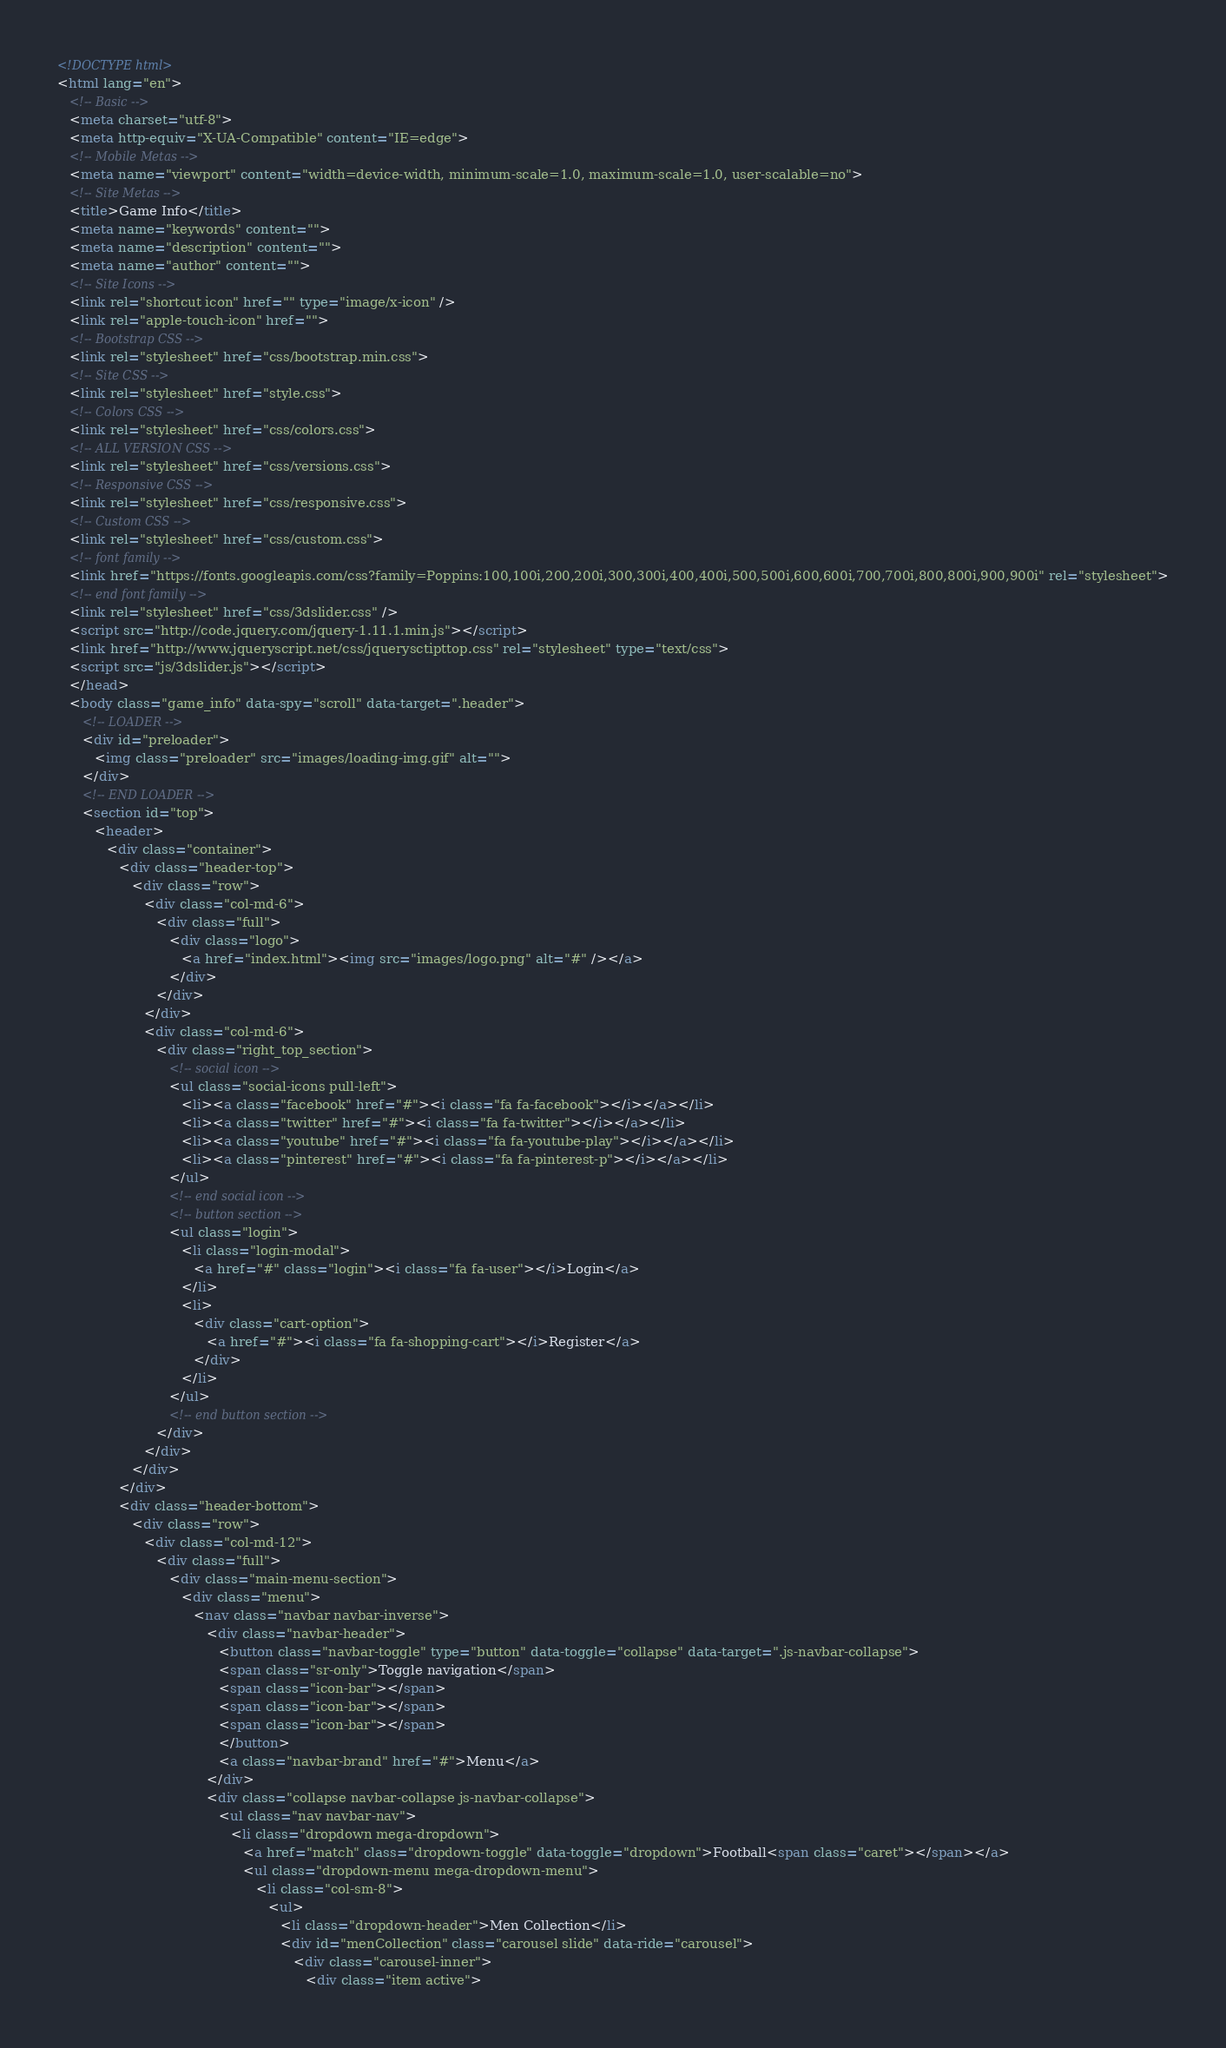<code> <loc_0><loc_0><loc_500><loc_500><_HTML_><!DOCTYPE html>
<html lang="en">
   <!-- Basic -->
   <meta charset="utf-8">
   <meta http-equiv="X-UA-Compatible" content="IE=edge">
   <!-- Mobile Metas -->
   <meta name="viewport" content="width=device-width, minimum-scale=1.0, maximum-scale=1.0, user-scalable=no">
   <!-- Site Metas -->
   <title>Game Info</title>
   <meta name="keywords" content="">
   <meta name="description" content="">
   <meta name="author" content="">
   <!-- Site Icons -->
   <link rel="shortcut icon" href="" type="image/x-icon" />
   <link rel="apple-touch-icon" href="">
   <!-- Bootstrap CSS -->
   <link rel="stylesheet" href="css/bootstrap.min.css">
   <!-- Site CSS -->
   <link rel="stylesheet" href="style.css">
   <!-- Colors CSS -->
   <link rel="stylesheet" href="css/colors.css">
   <!-- ALL VERSION CSS -->	
   <link rel="stylesheet" href="css/versions.css">
   <!-- Responsive CSS -->
   <link rel="stylesheet" href="css/responsive.css">
   <!-- Custom CSS -->
   <link rel="stylesheet" href="css/custom.css">
   <!-- font family -->
   <link href="https://fonts.googleapis.com/css?family=Poppins:100,100i,200,200i,300,300i,400,400i,500,500i,600,600i,700,700i,800,800i,900,900i" rel="stylesheet">
   <!-- end font family -->
   <link rel="stylesheet" href="css/3dslider.css" />
   <script src="http://code.jquery.com/jquery-1.11.1.min.js"></script>
   <link href="http://www.jqueryscript.net/css/jquerysctipttop.css" rel="stylesheet" type="text/css">
   <script src="js/3dslider.js"></script>
   </head>
   <body class="game_info" data-spy="scroll" data-target=".header">
      <!-- LOADER -->
      <div id="preloader">
         <img class="preloader" src="images/loading-img.gif" alt="">
      </div>
      <!-- END LOADER -->
      <section id="top">
         <header>
            <div class="container">
               <div class="header-top">
                  <div class="row">
                     <div class="col-md-6">
                        <div class="full">
                           <div class="logo">
                              <a href="index.html"><img src="images/logo.png" alt="#" /></a>
                           </div>
                        </div>
                     </div>
                     <div class="col-md-6">
                        <div class="right_top_section">
                           <!-- social icon -->
                           <ul class="social-icons pull-left">
                              <li><a class="facebook" href="#"><i class="fa fa-facebook"></i></a></li>
                              <li><a class="twitter" href="#"><i class="fa fa-twitter"></i></a></li>
                              <li><a class="youtube" href="#"><i class="fa fa-youtube-play"></i></a></li>
                              <li><a class="pinterest" href="#"><i class="fa fa-pinterest-p"></i></a></li>
                           </ul>
                           <!-- end social icon -->
                           <!-- button section -->
                           <ul class="login">
                              <li class="login-modal">
                                 <a href="#" class="login"><i class="fa fa-user"></i>Login</a>
                              </li>
                              <li>
                                 <div class="cart-option">
                                    <a href="#"><i class="fa fa-shopping-cart"></i>Register</a>
                                 </div>
                              </li>
                           </ul>
                           <!-- end button section -->
                        </div>
                     </div>
                  </div>
               </div>
               <div class="header-bottom">
                  <div class="row">
                     <div class="col-md-12">
                        <div class="full">
                           <div class="main-menu-section">
                              <div class="menu">
                                 <nav class="navbar navbar-inverse">
                                    <div class="navbar-header">
                                       <button class="navbar-toggle" type="button" data-toggle="collapse" data-target=".js-navbar-collapse">
                                       <span class="sr-only">Toggle navigation</span>
                                       <span class="icon-bar"></span>
                                       <span class="icon-bar"></span>
                                       <span class="icon-bar"></span>
                                       </button>
                                       <a class="navbar-brand" href="#">Menu</a>
                                    </div>
                                    <div class="collapse navbar-collapse js-navbar-collapse">
                                       <ul class="nav navbar-nav">
                                          <li class="dropdown mega-dropdown">
                                             <a href="match" class="dropdown-toggle" data-toggle="dropdown">Football<span class="caret"></span></a>				
                                             <ul class="dropdown-menu mega-dropdown-menu">
                                                <li class="col-sm-8">
                                                   <ul>
                                                      <li class="dropdown-header">Men Collection</li>
                                                      <div id="menCollection" class="carousel slide" data-ride="carousel">
                                                         <div class="carousel-inner">
                                                            <div class="item active"></code> 